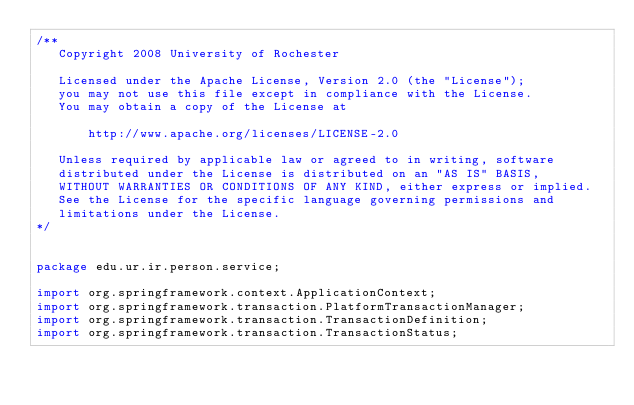Convert code to text. <code><loc_0><loc_0><loc_500><loc_500><_Java_>/**  
   Copyright 2008 University of Rochester

   Licensed under the Apache License, Version 2.0 (the "License");
   you may not use this file except in compliance with the License.
   You may obtain a copy of the License at

       http://www.apache.org/licenses/LICENSE-2.0

   Unless required by applicable law or agreed to in writing, software
   distributed under the License is distributed on an "AS IS" BASIS,
   WITHOUT WARRANTIES OR CONDITIONS OF ANY KIND, either express or implied.
   See the License for the specific language governing permissions and
   limitations under the License.
*/  


package edu.ur.ir.person.service;

import org.springframework.context.ApplicationContext;
import org.springframework.transaction.PlatformTransactionManager;
import org.springframework.transaction.TransactionDefinition;
import org.springframework.transaction.TransactionStatus;</code> 